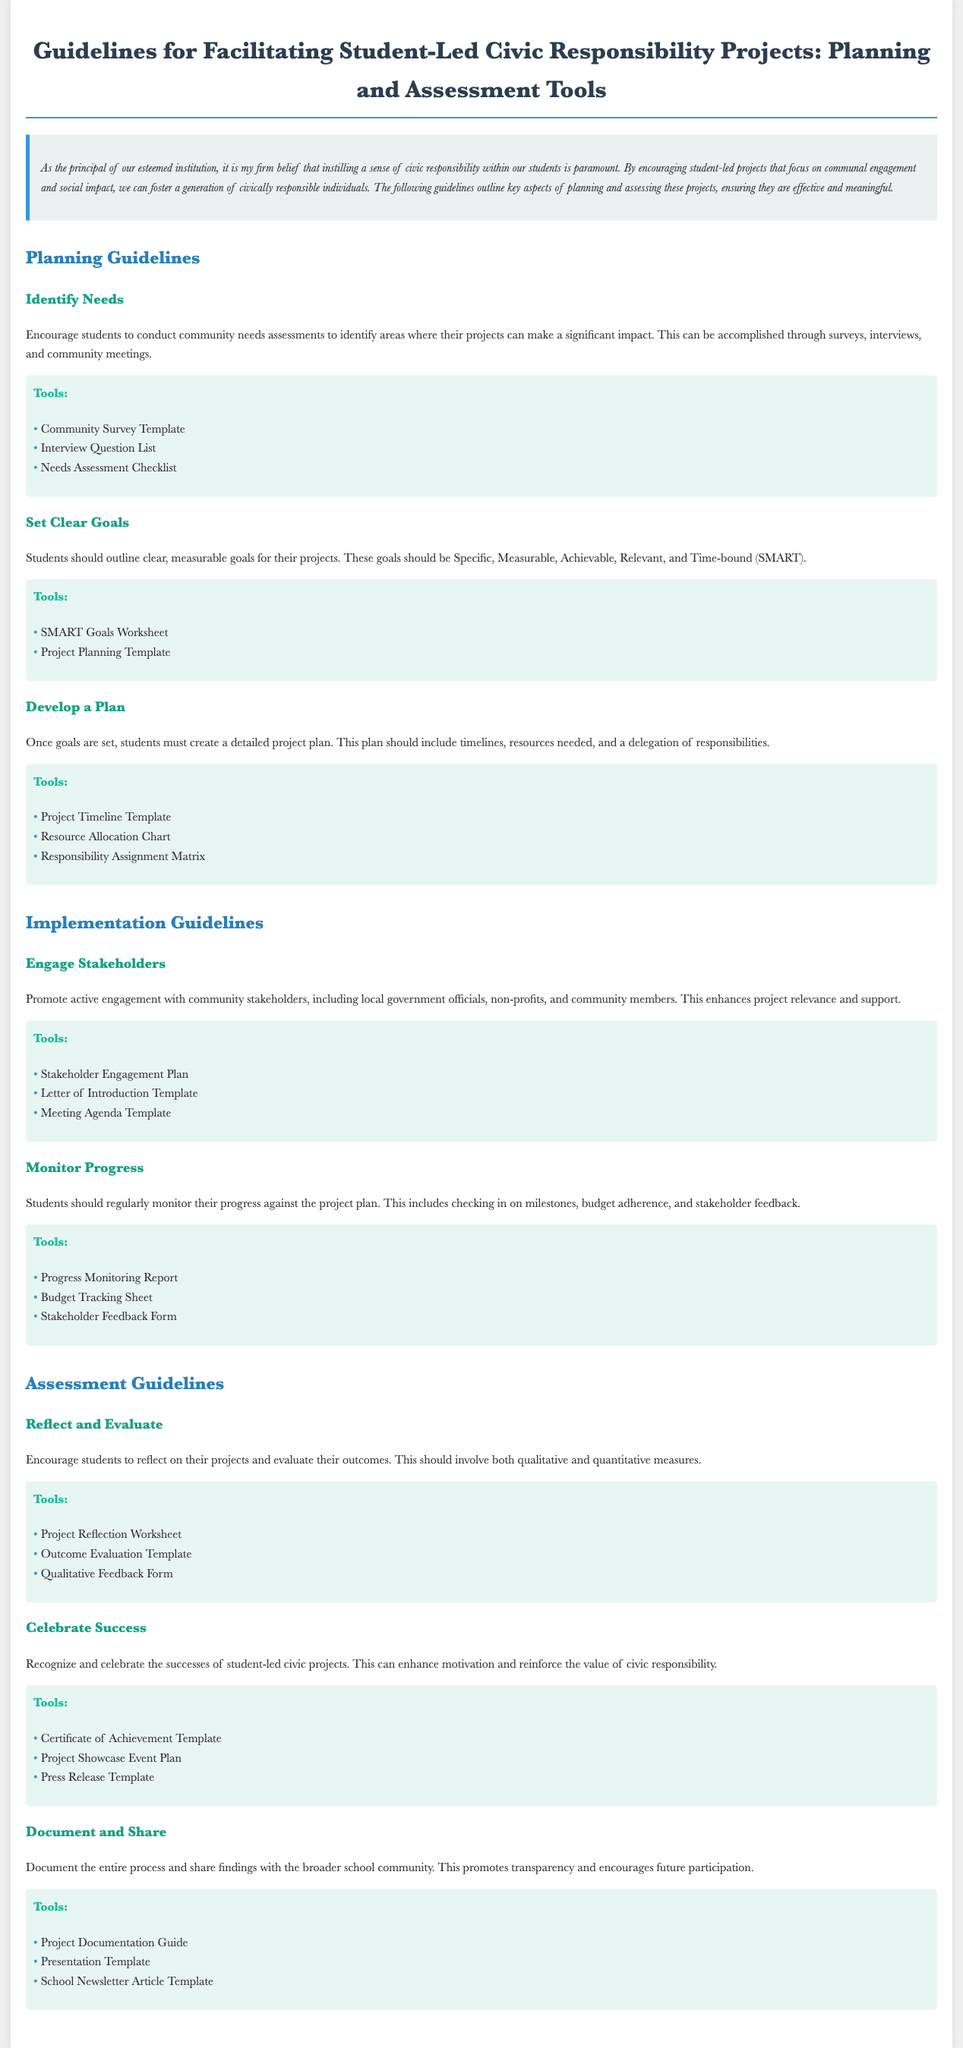what is the title of the document? The title is located in the header section of the document, providing an overview of its content regarding civic responsibility projects.
Answer: Guidelines for Facilitating Student-Led Civic Responsibility Projects: Planning and Assessment Tools what should students conduct to identify project needs? The document mentions a specific activity that involves gathering information from the community to ensure the project is relevant.
Answer: community needs assessments what framework should students use to outline project goals? The guidelines suggest a specific acronym that helps in setting effective project goals, focusing on clarity and measurability.
Answer: SMART what is one tool listed for monitoring project progress? The document offers a specific tool designed to help track the ongoing status of the project against set plans.
Answer: Progress Monitoring Report what should students do to celebrate project successes? The guidelines recommend a specific activity that enhances motivation and acknowledges student efforts after project completion.
Answer: Celebrate Success what is advised for engaging community stakeholders? The document suggests an approach to ensure active participation and support from external parties in the project.
Answer: Engage Stakeholders what type of evaluation should students conduct on their projects? The document emphasizes the importance of reflecting on various aspects of the project to assess its outcomes effectively.
Answer: Reflect and Evaluate which tool can be used for presenting project findings? The document lists tools that facilitate the sharing of project information with a wider audience.
Answer: Presentation Template what is one purpose of documenting the project process? The guidelines identify a significant benefit of thorough documentation that encourages future involvement in civic projects.
Answer: Promote transparency 